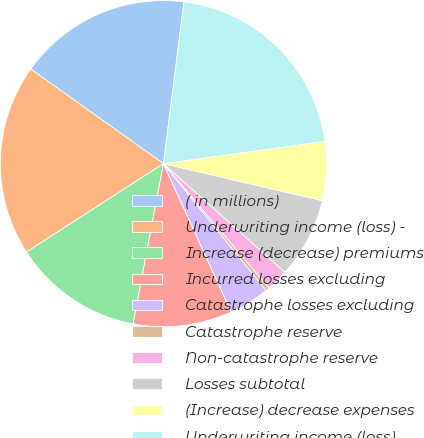Convert chart. <chart><loc_0><loc_0><loc_500><loc_500><pie_chart><fcel>( in millions)<fcel>Underwriting income (loss) -<fcel>Increase (decrease) premiums<fcel>Incurred losses excluding<fcel>Catastrophe losses excluding<fcel>Catastrophe reserve<fcel>Non-catastrophe reserve<fcel>Losses subtotal<fcel>(Increase) decrease expenses<fcel>Underwriting income (loss)<nl><fcel>17.16%<fcel>18.98%<fcel>12.9%<fcel>9.8%<fcel>4.01%<fcel>0.37%<fcel>2.19%<fcel>7.97%<fcel>5.83%<fcel>20.8%<nl></chart> 